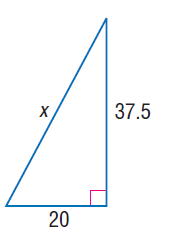Question: Find x.
Choices:
A. 20
B. 37.5
C. 42.5
D. 45
Answer with the letter. Answer: C 